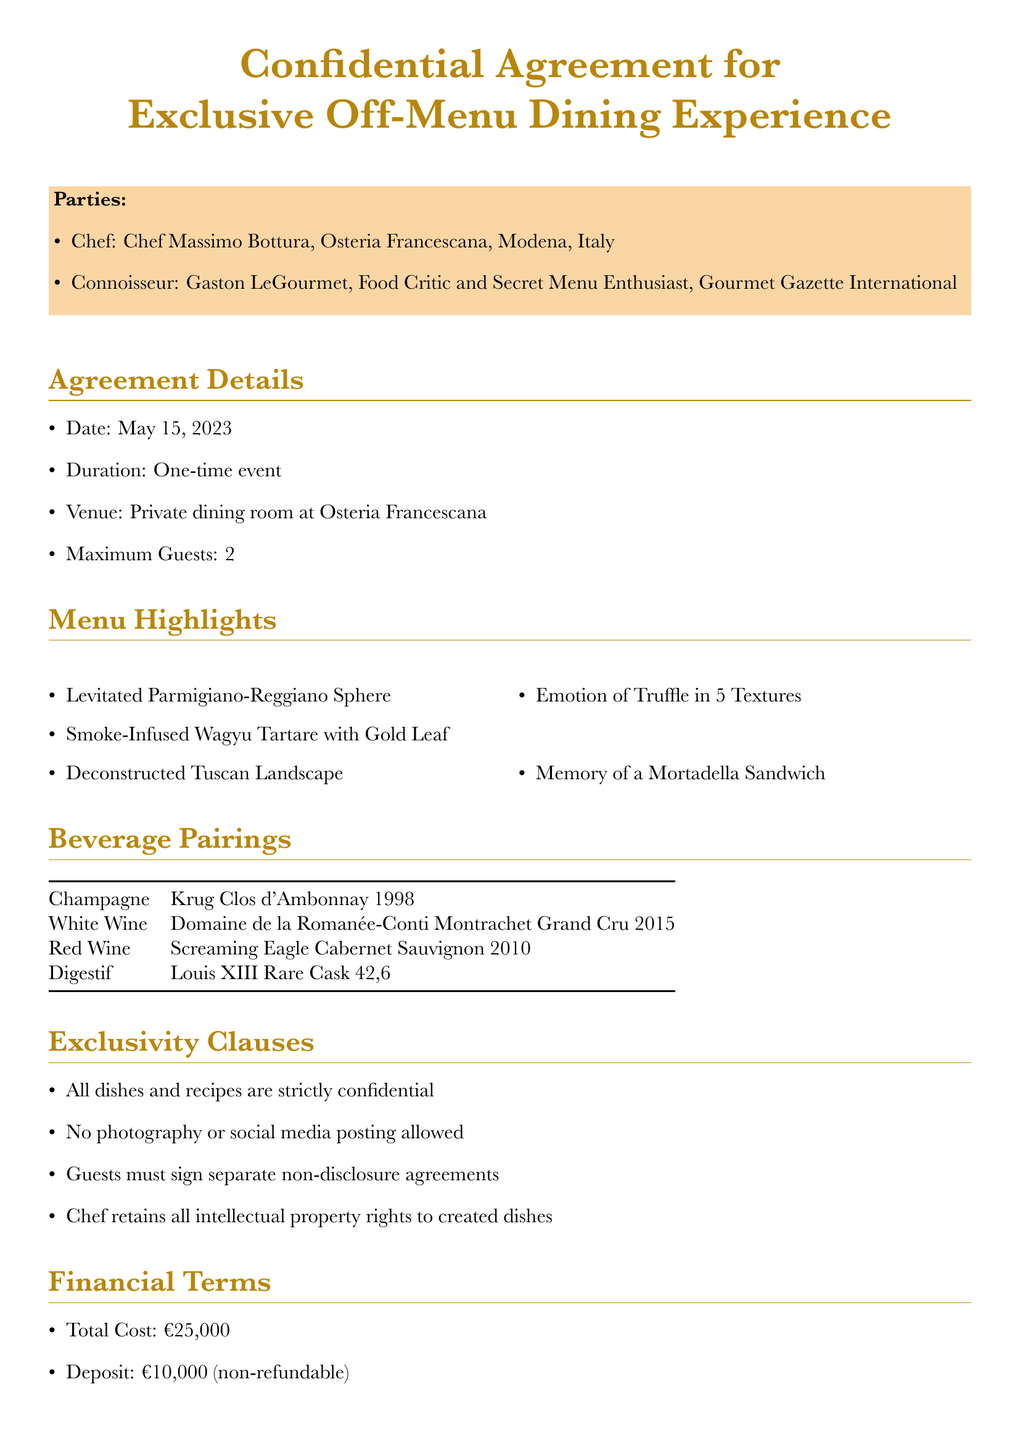What is the name of the chef? The document specifies the name of the chef involved in the agreement, which is Chef Massimo Bottura.
Answer: Chef Massimo Bottura What is the total cost of the dining experience? The document outlines the financial terms, including the total cost which is clearly stated as €25,000.
Answer: €25,000 What date was the agreement signed? The date of the agreement is mentioned in the agreement details section, indicated as May 15, 2023.
Answer: May 15, 2023 How many guests are allowed for the dining experience? The maximum number of guests specified in the document is found in the agreement details, stating it is a maximum of 2 guests.
Answer: 2 What is the cancellation policy outlined in the document? The cancellation policy is detailed, stating that full payment is required if canceled within 14 days of the event.
Answer: Full payment required if cancelled within 14 days of the event What is the souvenir provided to the connoisseur? The document lists the additional services, including a personalized, signed copy of Chef Bottura's latest cookbook as a souvenir.
Answer: Personalized, signed copy of Chef Bottura's latest cookbook What type of vehicle is provided for transportation? The additional services section indicates the type of transportation offered, which is a chauffeur-driven Rolls-Royce Phantom.
Answer: Chauffeur-driven Rolls-Royce Phantom What is the governing law for the agreement? The legal considerations section specifies that the governing law for the agreement is the Italian Civil Code.
Answer: Italian Civil Code 